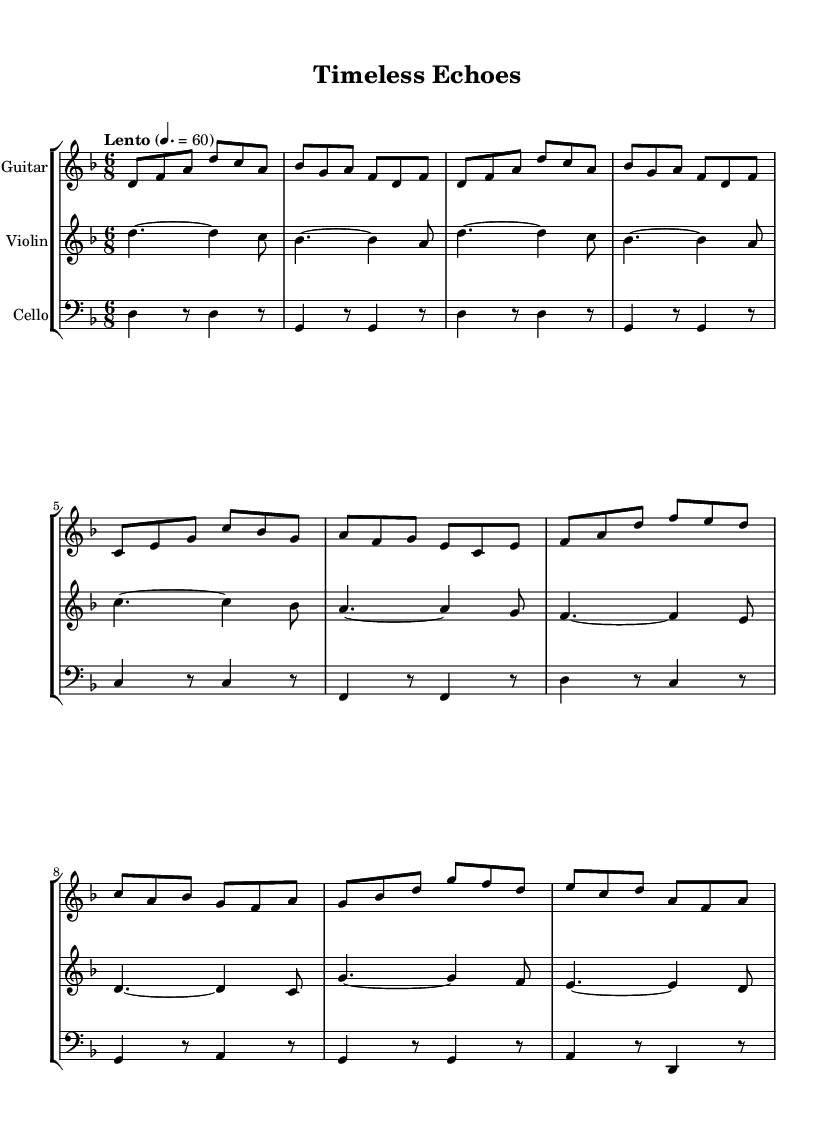What is the key signature of this music? The key signature in the sheet music shows two flats, indicating that the piece is in the key of D minor. This is determined by identifying the flats in the key signature area at the beginning of the staff.
Answer: D minor What is the time signature of the piece? The time signature is located at the beginning of the music and is noted as 6/8. This means there are six eighth notes in each measure, which is visually represented in the time signature display.
Answer: 6/8 What is the tempo marking for this piece? The tempo marking is specified in Italian terms and is indicated at the beginning of the piece as "Lento" with a metronome marking of 60. This denotes a slow pace for the performance.
Answer: Lento Which instrument plays the melody predominantly in this piece? The melody is primarily played by the violin, as it often carries the main melodic line throughout the score, with other instruments providing accompaniment.
Answer: Violin How many measures are in the main section of the piece? By counting the bar lines in the music, one can determine that there are a total of 16 measures in the primary thematic section. Each measure is delineated by vertical lines between groups of notes.
Answer: 16 What is the primary texture of this folk piece? The piece features a homophonic texture, where the melody (typically played by the violin) is supported by harmonic accompaniment from the guitar and cello, creating an organizational hierarchy among the parts.
Answer: Homophonic What feeling or mood is this piece likely intended to evoke? The contemplative and tied-to-the-concept of time implies a serene, introspective mood. Instrumentation and tempo choices reinforce this emotional quality in a folk context.
Answer: Contemplative 